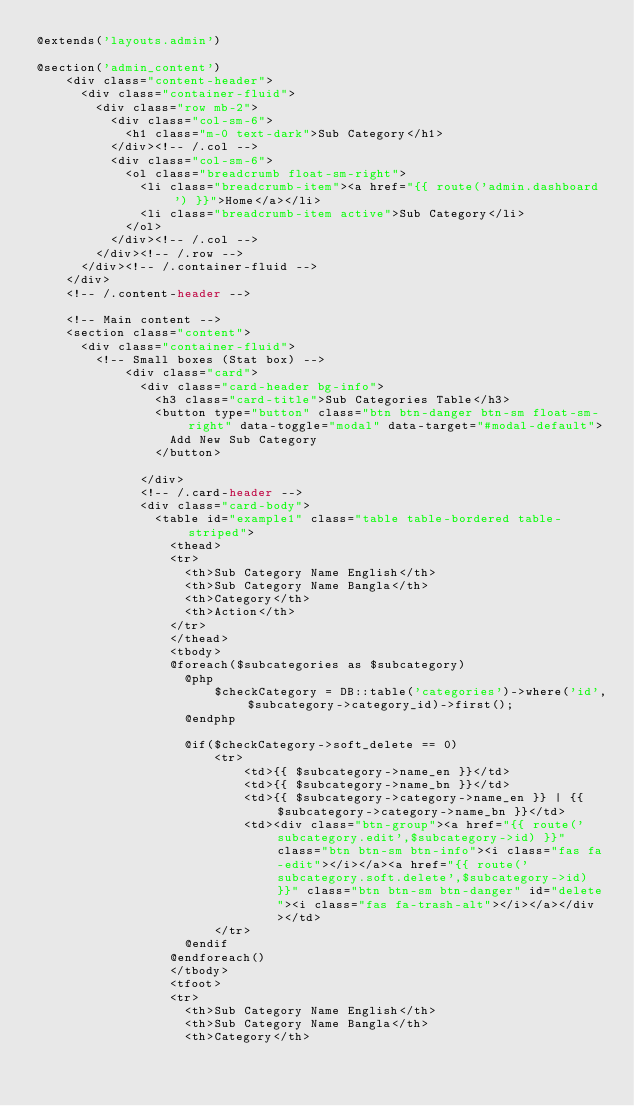Convert code to text. <code><loc_0><loc_0><loc_500><loc_500><_PHP_>@extends('layouts.admin')

@section('admin_content')
	<div class="content-header">
	  <div class="container-fluid">
	    <div class="row mb-2">
	      <div class="col-sm-6">
	        <h1 class="m-0 text-dark">Sub Category</h1>
	      </div><!-- /.col -->
	      <div class="col-sm-6">
	        <ol class="breadcrumb float-sm-right">
	          <li class="breadcrumb-item"><a href="{{ route('admin.dashboard') }}">Home</a></li>
	          <li class="breadcrumb-item active">Sub Category</li>
	        </ol>
	      </div><!-- /.col -->
	    </div><!-- /.row -->
	  </div><!-- /.container-fluid -->
	</div>
	<!-- /.content-header -->

	<!-- Main content -->
	<section class="content">
	  <div class="container-fluid">
	    <!-- Small boxes (Stat box) -->
			<div class="card">
			  <div class="card-header bg-info">
			    <h3 class="card-title">Sub Categories Table</h3>
			    <button type="button" class="btn btn-danger btn-sm float-sm-right" data-toggle="modal" data-target="#modal-default">
                  Add New Sub Category
                </button>
                
			  </div>
			  <!-- /.card-header -->
			  <div class="card-body">
			    <table id="example1" class="table table-bordered table-striped">
			      <thead>
			      <tr>
			        <th>Sub Category Name English</th>
			        <th>Sub Category Name Bangla</th>
			        <th>Category</th>
			        <th>Action</th>
			      </tr>
			      </thead>
			      <tbody>
			      @foreach($subcategories as $subcategory)
				    @php
				    	$checkCategory = DB::table('categories')->where('id',$subcategory->category_id)->first();
				    @endphp

				    @if($checkCategory->soft_delete == 0)
						<tr>
					        <td>{{ $subcategory->name_en }}</td>
					        <td>{{ $subcategory->name_bn }}</td>
					        <td>{{ $subcategory->category->name_en }} | {{ $subcategory->category->name_bn }}</td>
					        <td><div class="btn-group"><a href="{{ route('subcategory.edit',$subcategory->id) }}" class="btn btn-sm btn-info"><i class="fas fa-edit"></i></a><a href="{{ route('subcategory.soft.delete',$subcategory->id) }}" class="btn btn-sm btn-danger" id="delete"><i class="fas fa-trash-alt"></i></a></div></td>
				    	</tr>
				    @endif
			      @endforeach()
			      </tbody>
			      <tfoot>
			      <tr>
			        <th>Sub Category Name English</th>
			        <th>Sub Category Name Bangla</th>
			        <th>Category</th></code> 